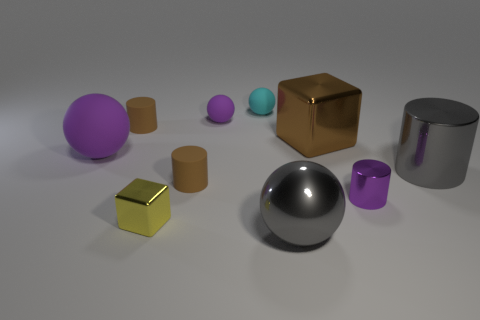What number of cylinders are the same color as the big metal cube?
Make the answer very short. 2. The purple object that is the same material as the brown block is what size?
Keep it short and to the point. Small. There is a block in front of the small purple thing that is in front of the brown matte cylinder right of the tiny yellow thing; how big is it?
Provide a succinct answer. Small. There is a gray metallic ball in front of the big block; what size is it?
Your answer should be very brief. Large. How many blue things are rubber cylinders or balls?
Offer a very short reply. 0. Are there any brown objects of the same size as the gray sphere?
Make the answer very short. Yes. There is a purple sphere that is the same size as the gray sphere; what material is it?
Make the answer very short. Rubber. There is a brown object that is in front of the big purple matte sphere; is it the same size as the block that is in front of the tiny purple shiny object?
Provide a succinct answer. Yes. How many things are either big red blocks or objects that are right of the small cube?
Keep it short and to the point. 7. Are there any brown shiny objects that have the same shape as the small yellow object?
Offer a terse response. Yes. 